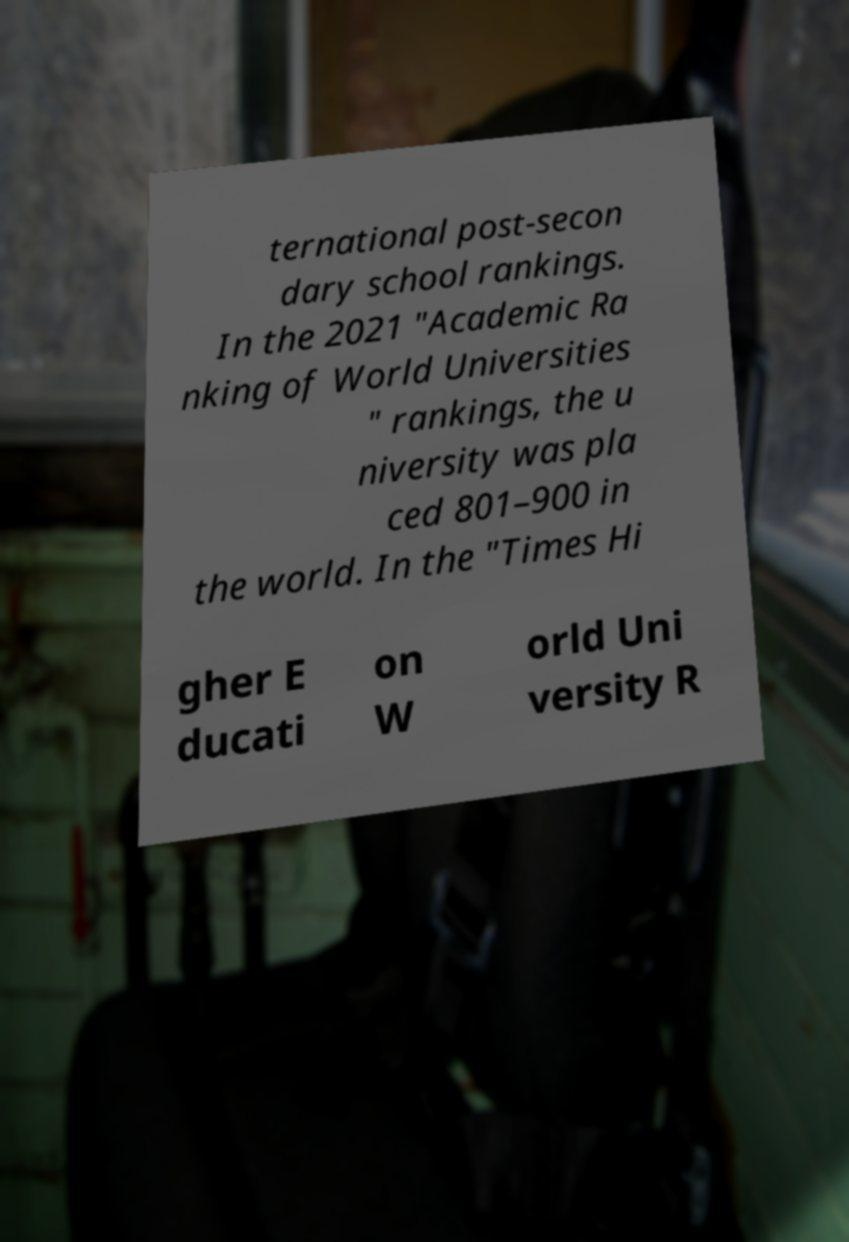Can you accurately transcribe the text from the provided image for me? ternational post-secon dary school rankings. In the 2021 "Academic Ra nking of World Universities " rankings, the u niversity was pla ced 801–900 in the world. In the "Times Hi gher E ducati on W orld Uni versity R 